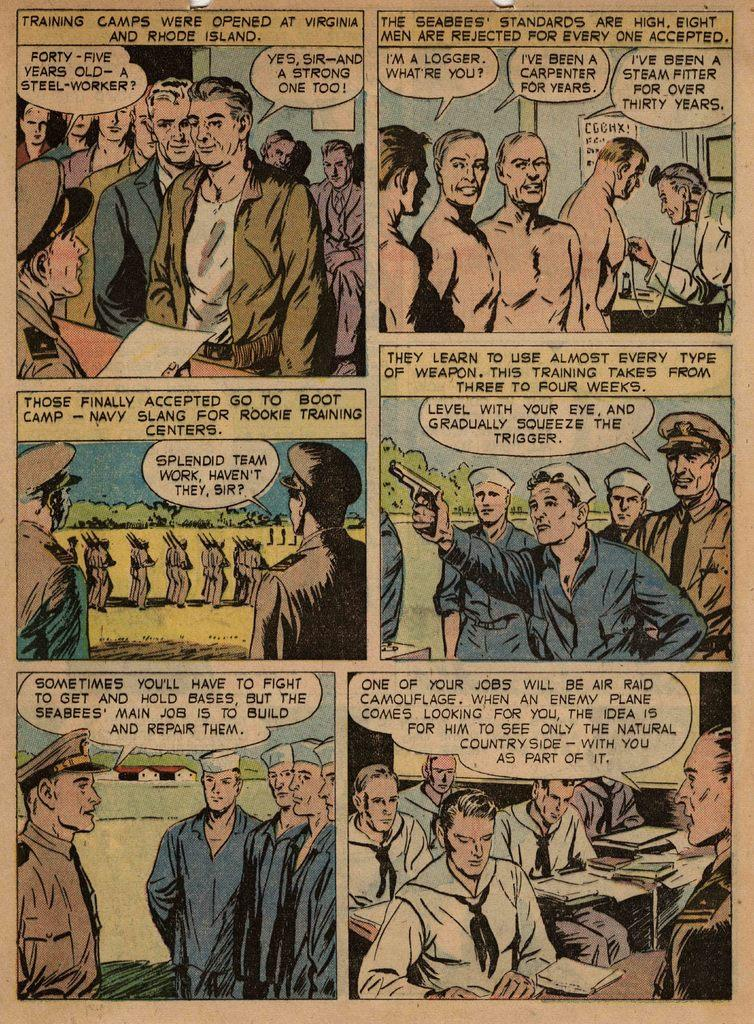<image>
Describe the image concisely. A comic page that begins with "Training Camps Were Opened At Virginia And Rhode Island." 